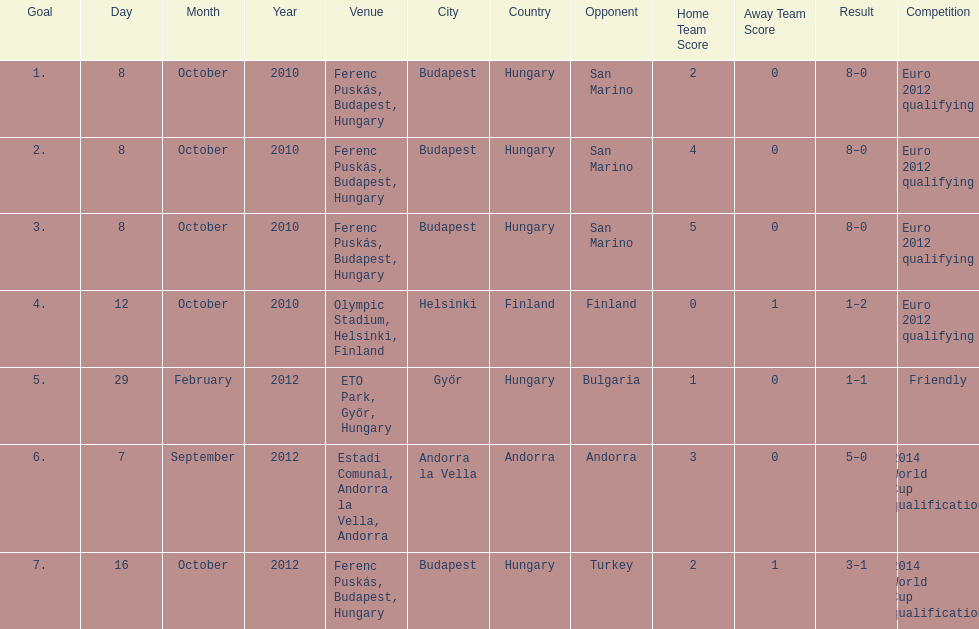What is the total number of international goals ádám szalai has made? 7. 